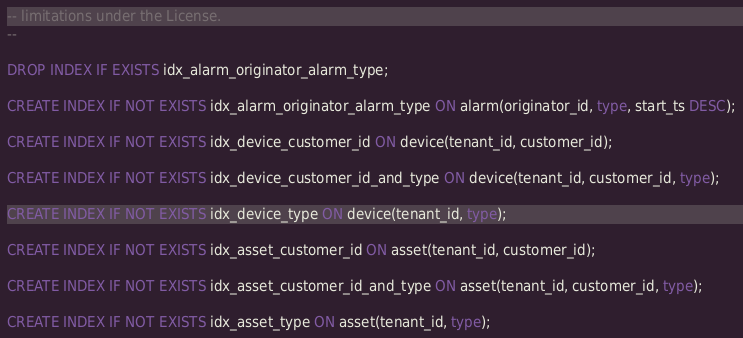<code> <loc_0><loc_0><loc_500><loc_500><_SQL_>-- limitations under the License.
--

DROP INDEX IF EXISTS idx_alarm_originator_alarm_type;

CREATE INDEX IF NOT EXISTS idx_alarm_originator_alarm_type ON alarm(originator_id, type, start_ts DESC);

CREATE INDEX IF NOT EXISTS idx_device_customer_id ON device(tenant_id, customer_id);

CREATE INDEX IF NOT EXISTS idx_device_customer_id_and_type ON device(tenant_id, customer_id, type);

CREATE INDEX IF NOT EXISTS idx_device_type ON device(tenant_id, type);

CREATE INDEX IF NOT EXISTS idx_asset_customer_id ON asset(tenant_id, customer_id);

CREATE INDEX IF NOT EXISTS idx_asset_customer_id_and_type ON asset(tenant_id, customer_id, type);

CREATE INDEX IF NOT EXISTS idx_asset_type ON asset(tenant_id, type);</code> 